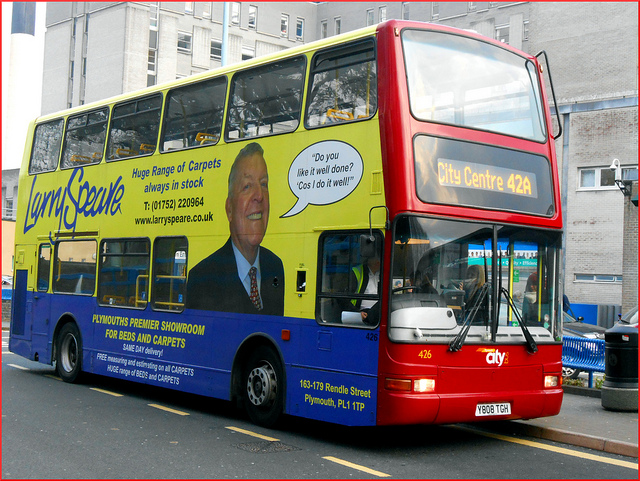Identify the text displayed in this image. 42A SHOWROOM Centre 426 CARPETS TGH PL1 Street 179 CARPETS FOR BEDS AND PREMIER PLYMOUTHS do it well well a done? You Do WWW.larryspeare.co.uk T 01752 220964 in always stock Carpets of Range Huge Speare Larry 